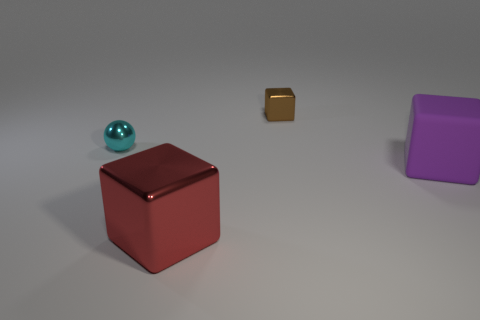Is there any other thing that has the same shape as the small cyan metallic object?
Give a very brief answer. No. Are there the same number of cyan shiny things in front of the purple object and objects right of the tiny brown object?
Keep it short and to the point. No. There is a thing that is both behind the purple object and right of the red metallic object; what shape is it?
Your answer should be very brief. Cube. There is a red cube; what number of small spheres are to the left of it?
Offer a terse response. 1. What number of other things are the same shape as the cyan object?
Your response must be concise. 0. Are there fewer yellow cubes than objects?
Make the answer very short. Yes. There is a object that is behind the large matte thing and to the right of the small ball; what is its size?
Your answer should be compact. Small. How big is the shiny ball that is in front of the metal block that is behind the cube right of the tiny brown shiny cube?
Provide a short and direct response. Small. How big is the purple rubber block?
Your answer should be compact. Large. Is there anything else that has the same material as the purple block?
Your answer should be compact. No. 